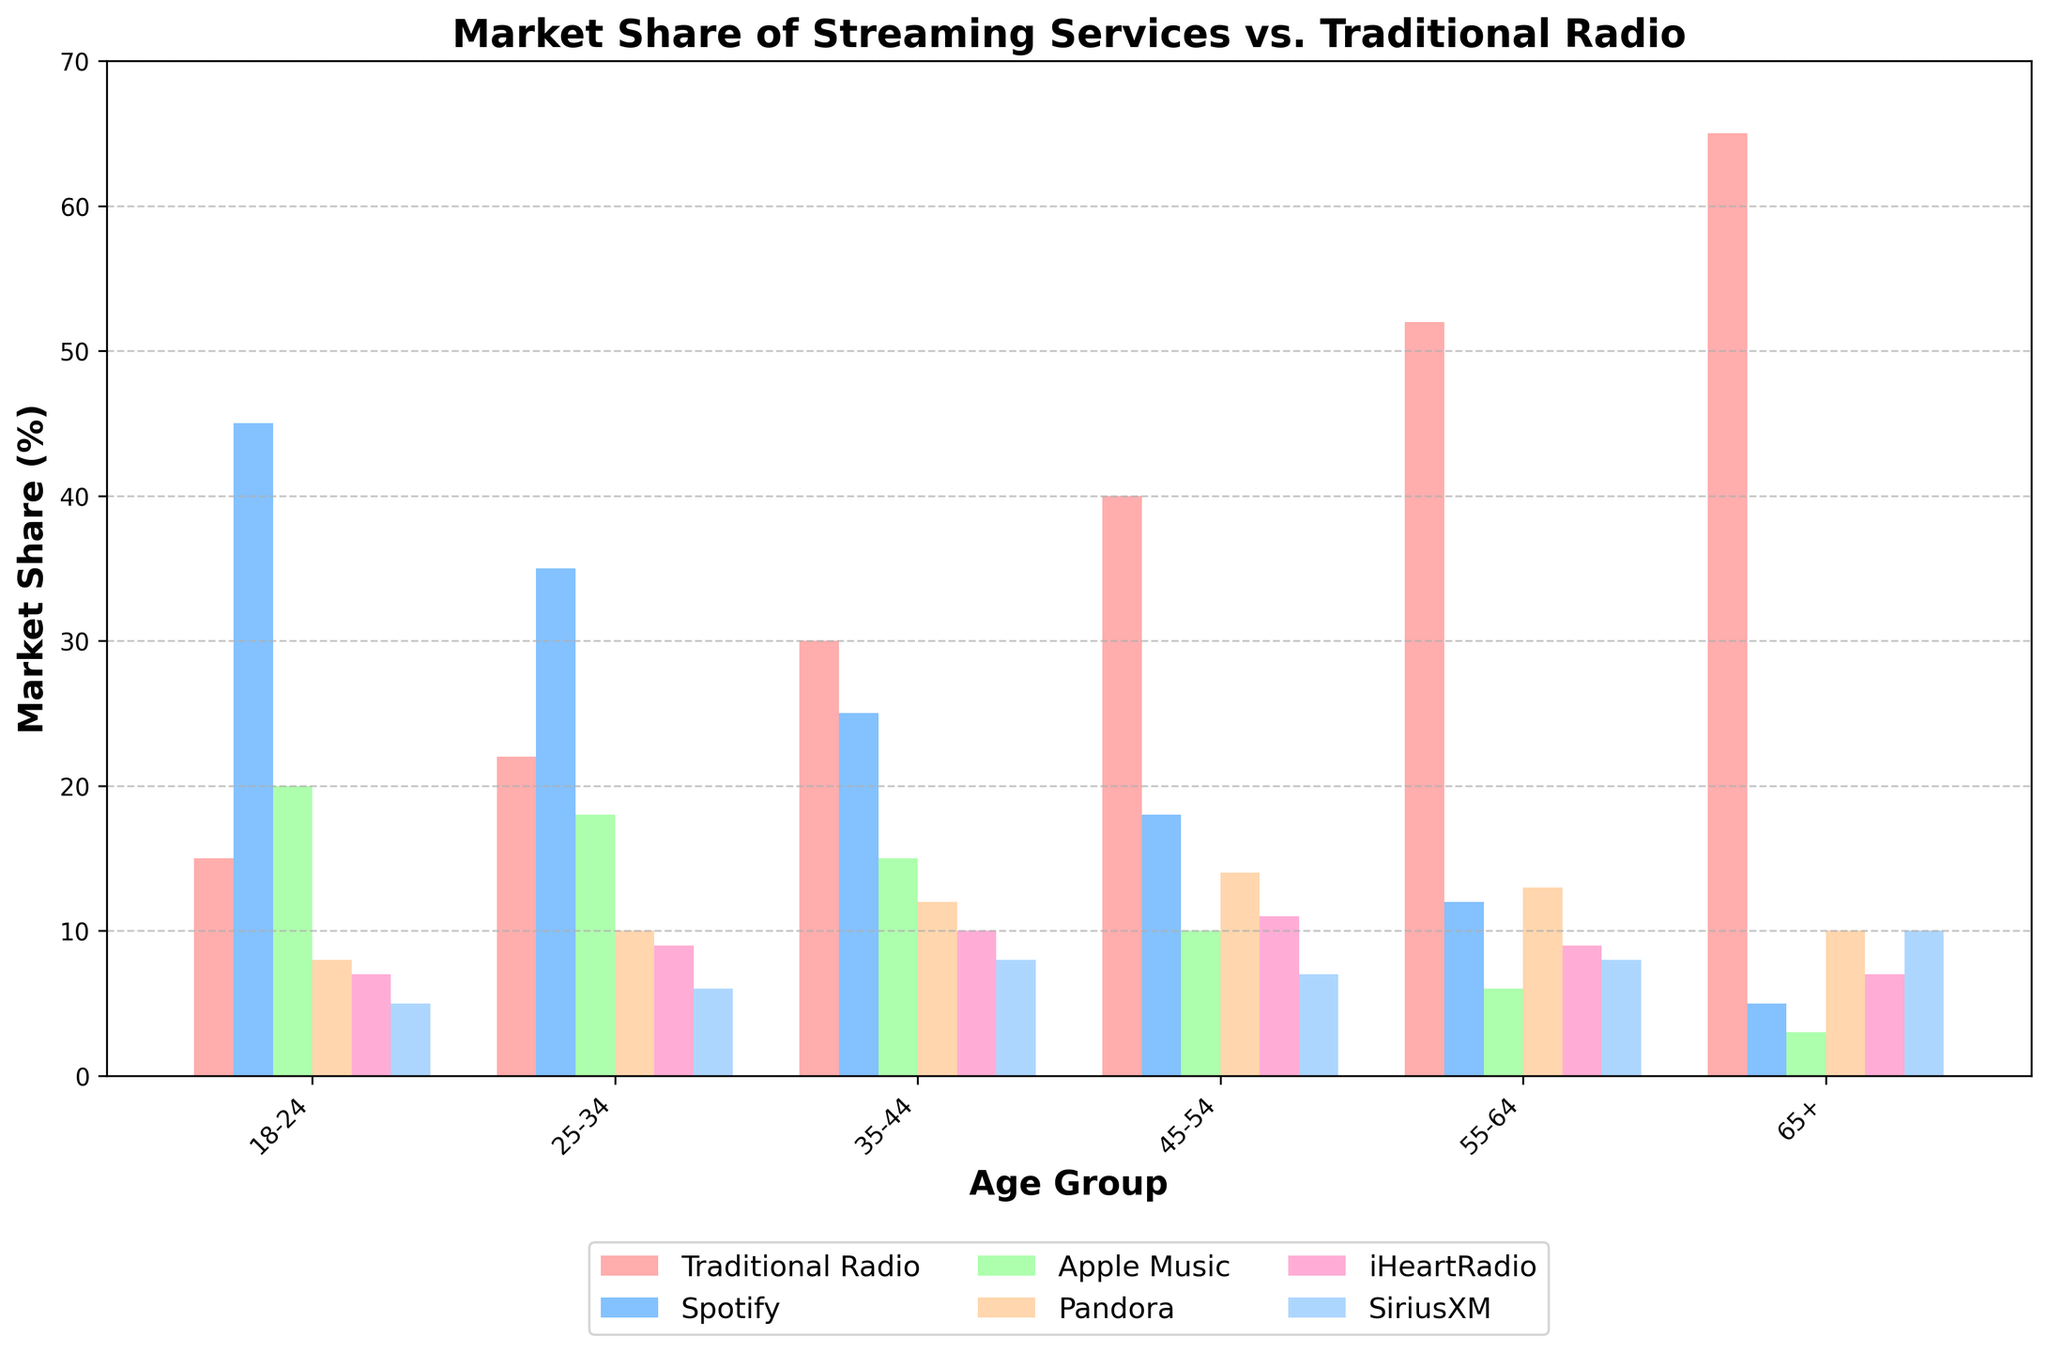What is the market share of Traditional Radio in the 35-44 age group? Look at the bar corresponding to Traditional Radio in the 35-44 age group.
Answer: 30% How does Spotify's market share compare between the 18-24 and 45-54 age groups? Compare the heights of the Spotify bars for the 18-24 and 45-54 age groups, 45% and 18% respectively.
Answer: Spotify has a higher market share in the 18-24 age group Which age group has the highest market share for Traditional Radio? Identify the tallest bar representing Traditional Radio among all age groups.
Answer: 65+ Which two streaming services have the smallest market share in the 55-64 age group? Identify the two shortest bars within the 55-64 age group, corresponding to 6% and 9% for Apple Music and iHeartRadio, respectively.
Answer: Apple Music and iHeartRadio What is the sum of the market shares for iHeartRadio and SiriusXM in the 45-54 age group? Add the values of the bars representing iHeartRadio and SiriusXM, which are 11% and 7% respectively.
Answer: 18% How does the market share of SiriusXM in the 65+ age group compare to the 18-24 age group? Compare the heights of the SiriusXM bars for both age groups (10% in 65+ and 5% in 18-24).
Answer: SiriusXM has a higher market share in the 65+ age group Which streaming service shows the most significant decrease in market share as the age group increases from 18-24 to 65+? Compare the changes for each streaming service across the age groups. Notice Spotify drops from 45% to 5%.
Answer: Spotify What is the difference in market share between Traditional Radio and Spotify in the 25-34 age group? Subtract Spotify's market share (35%) from Traditional Radio's market share (22%) in the 25-34 age group.
Answer: -13% Which age group has an equal market share for Pandora and Traditional Radio, if any? Scan through the bars of both Pandora and Traditional Radio to check for equal heights and percentages.
Answer: None What is the average market share of Apple Music across all age groups? Sum the market shares of Apple Music in all age groups and divide by the number of age groups: (20% + 18% + 15% + 10% + 6% + 3%) / 6.
Answer: 12% 